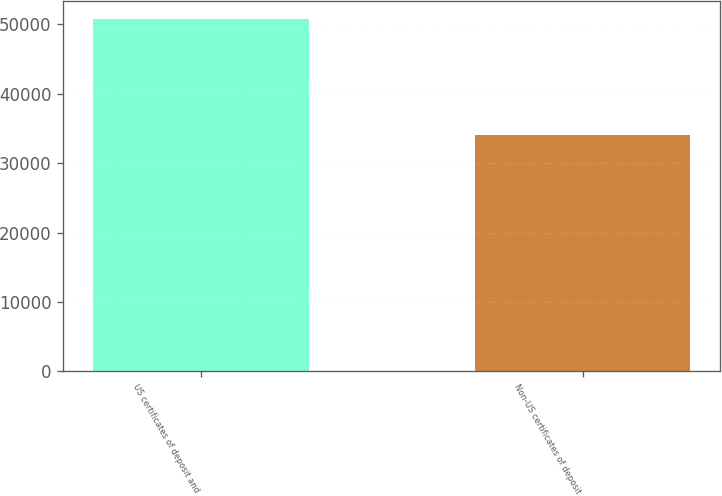Convert chart to OTSL. <chart><loc_0><loc_0><loc_500><loc_500><bar_chart><fcel>US certificates of deposit and<fcel>Non-US certificates of deposit<nl><fcel>50814<fcel>33987<nl></chart> 